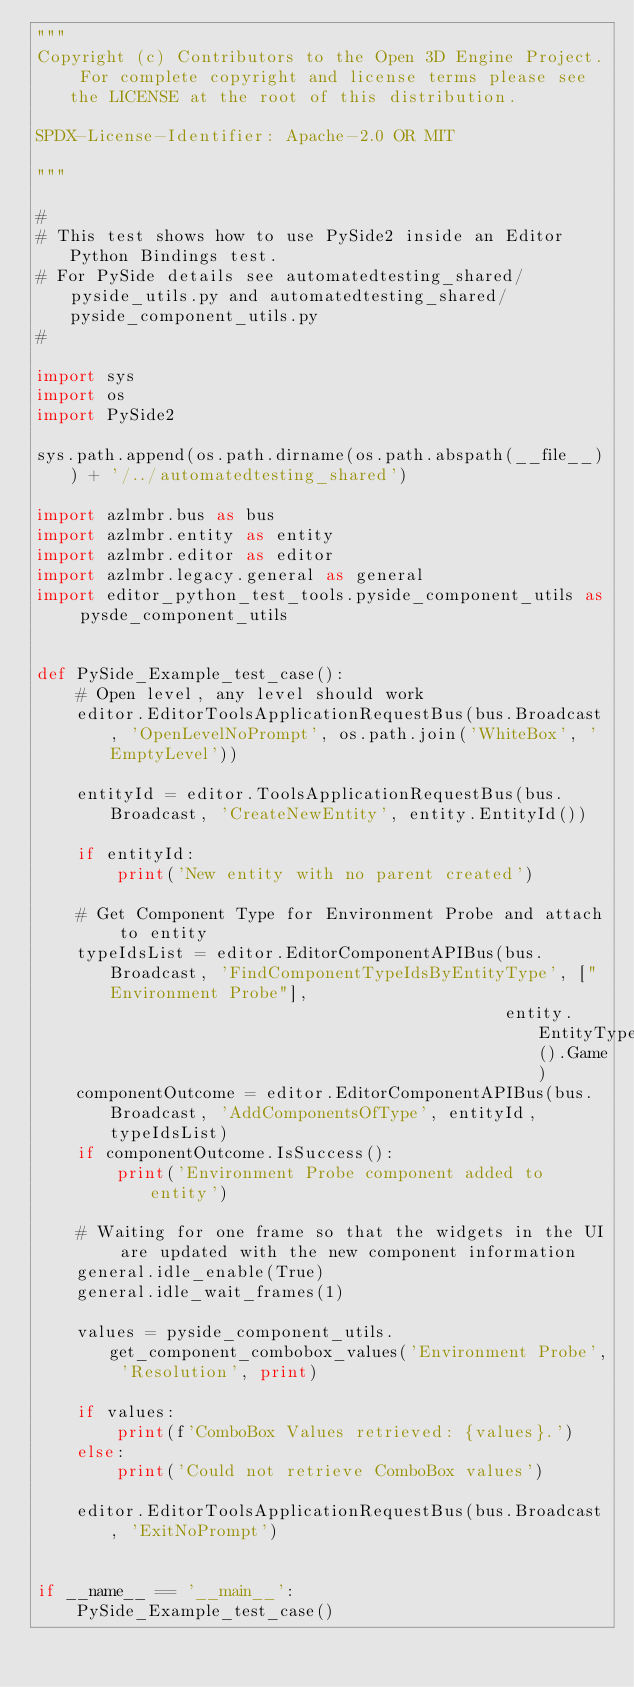<code> <loc_0><loc_0><loc_500><loc_500><_Python_>"""
Copyright (c) Contributors to the Open 3D Engine Project. For complete copyright and license terms please see the LICENSE at the root of this distribution.

SPDX-License-Identifier: Apache-2.0 OR MIT

"""

#
# This test shows how to use PySide2 inside an Editor Python Bindings test.
# For PySide details see automatedtesting_shared/pyside_utils.py and automatedtesting_shared/pyside_component_utils.py
#

import sys
import os
import PySide2

sys.path.append(os.path.dirname(os.path.abspath(__file__)) + '/../automatedtesting_shared')

import azlmbr.bus as bus
import azlmbr.entity as entity
import azlmbr.editor as editor
import azlmbr.legacy.general as general
import editor_python_test_tools.pyside_component_utils as pysde_component_utils


def PySide_Example_test_case():
    # Open level, any level should work
    editor.EditorToolsApplicationRequestBus(bus.Broadcast, 'OpenLevelNoPrompt', os.path.join('WhiteBox', 'EmptyLevel'))

    entityId = editor.ToolsApplicationRequestBus(bus.Broadcast, 'CreateNewEntity', entity.EntityId())

    if entityId:
        print('New entity with no parent created')

    # Get Component Type for Environment Probe and attach to entity
    typeIdsList = editor.EditorComponentAPIBus(bus.Broadcast, 'FindComponentTypeIdsByEntityType', ["Environment Probe"],
                                               entity.EntityType().Game)
    componentOutcome = editor.EditorComponentAPIBus(bus.Broadcast, 'AddComponentsOfType', entityId, typeIdsList)
    if componentOutcome.IsSuccess():
        print('Environment Probe component added to entity')

    # Waiting for one frame so that the widgets in the UI are updated with the new component information
    general.idle_enable(True)
    general.idle_wait_frames(1)

    values = pyside_component_utils.get_component_combobox_values('Environment Probe', 'Resolution', print)

    if values:
        print(f'ComboBox Values retrieved: {values}.')
    else:
        print('Could not retrieve ComboBox values')

    editor.EditorToolsApplicationRequestBus(bus.Broadcast, 'ExitNoPrompt')


if __name__ == '__main__':
    PySide_Example_test_case()
</code> 